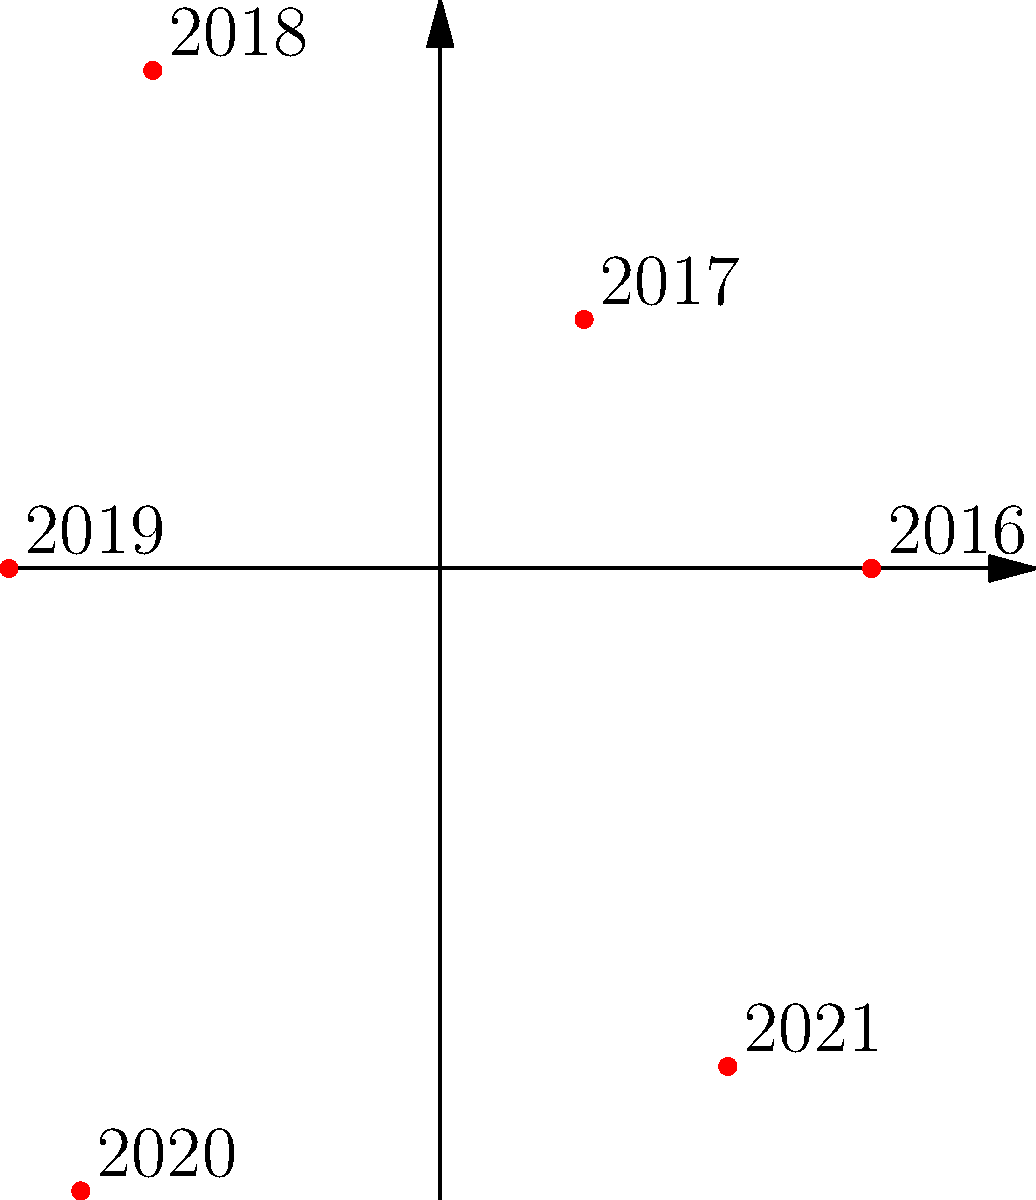Based on the polar coordinate visualization of Microsoft's product release cycles, which year shows an anomalous spike in releases that contradicts the company's usual strategy of gradual, iterative updates? To answer this question, we need to analyze the data points in the polar coordinate visualization:

1. Examine each year's release count:
   2016: 3 releases
   2017: 2 releases
   2018: 4 releases
   2019: 3 releases
   2020: 5 releases
   2021: 4 releases

2. Identify the general trend:
   Microsoft typically releases 2-4 products per year, with small variations.

3. Look for anomalies:
   2020 stands out with 5 releases, which is higher than the usual range.

4. Consider the context:
   As a tech journalist skeptical of Microsoft's strategies, this spike in 2020 contradicts the company's usual approach of gradual, iterative updates.

5. Conclusion:
   2020 shows an anomalous spike in releases, deviating from Microsoft's typical strategy.
Answer: 2020 